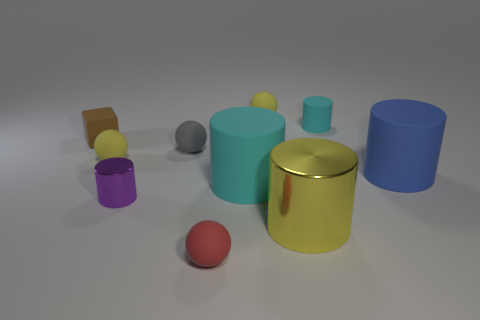There is a big cylinder that is behind the tiny metal cylinder and right of the large cyan cylinder; what material is it made of?
Make the answer very short. Rubber. Does the yellow ball that is left of the red matte thing have the same size as the small shiny thing?
Provide a succinct answer. Yes. What number of objects are both on the right side of the yellow shiny cylinder and in front of the tiny cyan rubber thing?
Keep it short and to the point. 1. What number of large cyan cylinders are behind the yellow matte thing behind the small yellow rubber ball that is on the left side of the small red matte sphere?
Provide a succinct answer. 0. What is the size of the other cylinder that is the same color as the tiny matte cylinder?
Provide a short and direct response. Large. What is the shape of the big yellow metallic object?
Offer a very short reply. Cylinder. How many tiny red balls have the same material as the large cyan cylinder?
Give a very brief answer. 1. The tiny cylinder that is made of the same material as the tiny gray thing is what color?
Give a very brief answer. Cyan. There is a brown matte object; does it have the same size as the sphere that is in front of the blue thing?
Offer a very short reply. Yes. What is the tiny yellow sphere that is to the left of the tiny yellow matte sphere behind the tiny yellow rubber thing to the left of the tiny red sphere made of?
Offer a terse response. Rubber. 